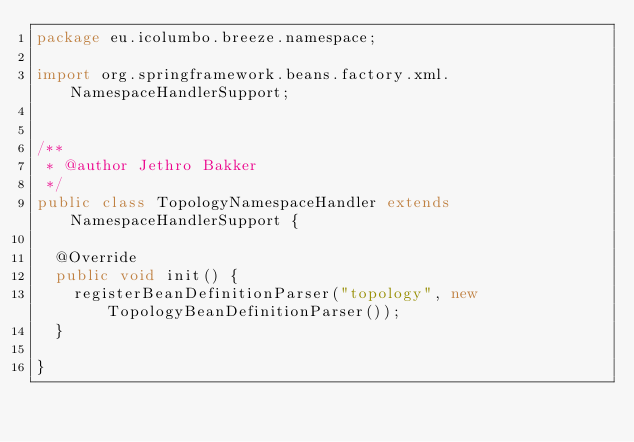Convert code to text. <code><loc_0><loc_0><loc_500><loc_500><_Java_>package eu.icolumbo.breeze.namespace;

import org.springframework.beans.factory.xml.NamespaceHandlerSupport;


/**
 * @author Jethro Bakker
 */
public class TopologyNamespaceHandler extends NamespaceHandlerSupport {

	@Override
	public void init() {
		registerBeanDefinitionParser("topology", new TopologyBeanDefinitionParser());
	}

}
</code> 